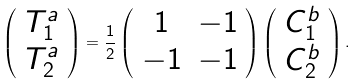Convert formula to latex. <formula><loc_0><loc_0><loc_500><loc_500>\left ( \begin{array} { c c } T _ { 1 } ^ { a } \\ T _ { 2 } ^ { a } \end{array} \right ) = \frac { 1 } { 2 } \left ( \begin{array} { c c } 1 & - 1 \\ - 1 & - 1 \end{array} \right ) \left ( \begin{array} { c c } C _ { 1 } ^ { b } \\ C _ { 2 } ^ { b } \end{array} \right ) .</formula> 